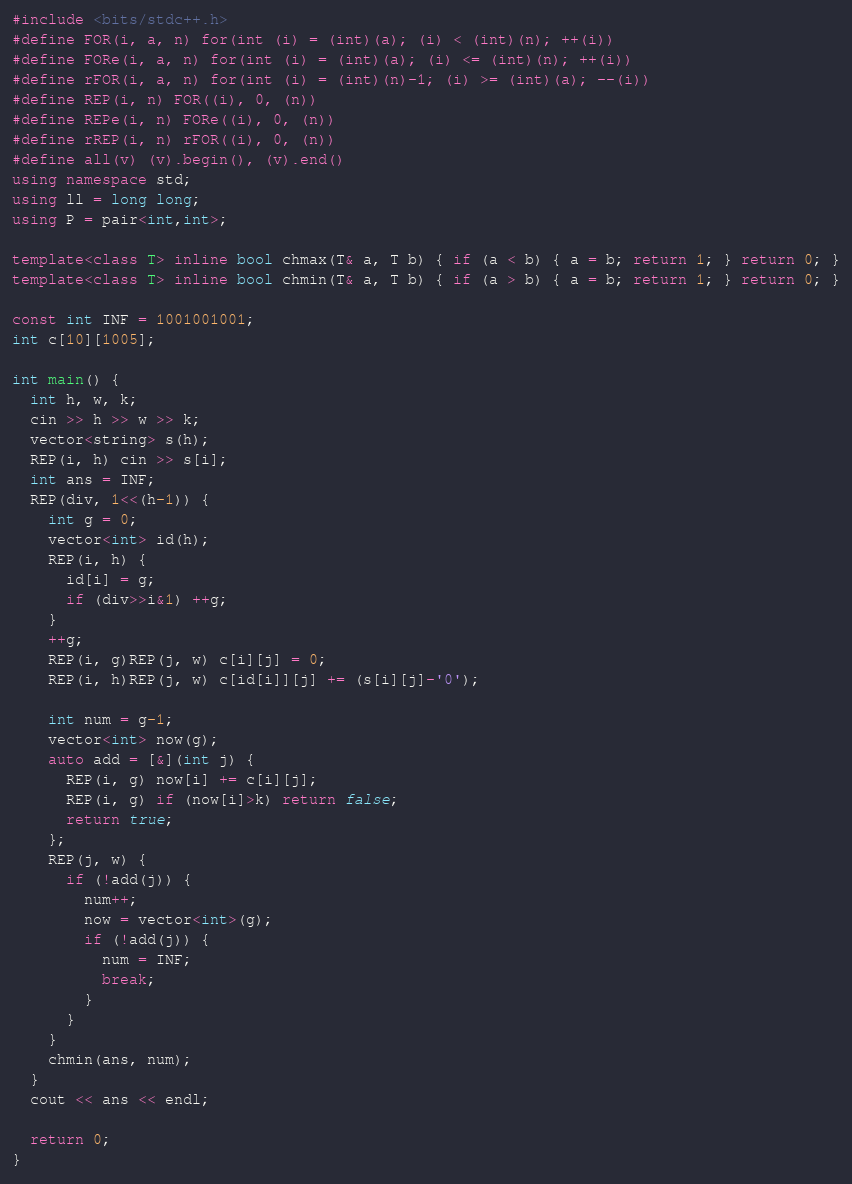<code> <loc_0><loc_0><loc_500><loc_500><_C++_>#include <bits/stdc++.h>
#define FOR(i, a, n) for(int (i) = (int)(a); (i) < (int)(n); ++(i))
#define FORe(i, a, n) for(int (i) = (int)(a); (i) <= (int)(n); ++(i))
#define rFOR(i, a, n) for(int (i) = (int)(n)-1; (i) >= (int)(a); --(i))
#define REP(i, n) FOR((i), 0, (n))
#define REPe(i, n) FORe((i), 0, (n))
#define rREP(i, n) rFOR((i), 0, (n))
#define all(v) (v).begin(), (v).end()
using namespace std;
using ll = long long;
using P = pair<int,int>;

template<class T> inline bool chmax(T& a, T b) { if (a < b) { a = b; return 1; } return 0; }
template<class T> inline bool chmin(T& a, T b) { if (a > b) { a = b; return 1; } return 0; }

const int INF = 1001001001;
int c[10][1005];

int main() {
  int h, w, k;
  cin >> h >> w >> k;
  vector<string> s(h);
  REP(i, h) cin >> s[i];
  int ans = INF;
  REP(div, 1<<(h-1)) {
    int g = 0;
    vector<int> id(h);
    REP(i, h) {
      id[i] = g;
      if (div>>i&1) ++g;
    }
    ++g;
    REP(i, g)REP(j, w) c[i][j] = 0;
    REP(i, h)REP(j, w) c[id[i]][j] += (s[i][j]-'0');

    int num = g-1;
    vector<int> now(g);
    auto add = [&](int j) {
      REP(i, g) now[i] += c[i][j];
      REP(i, g) if (now[i]>k) return false;
      return true;
    };
    REP(j, w) {
      if (!add(j)) {
        num++;
        now = vector<int>(g);
        if (!add(j)) {
          num = INF;
          break;
        }
      }
    }
    chmin(ans, num);
  }
  cout << ans << endl;

  return 0;
}</code> 